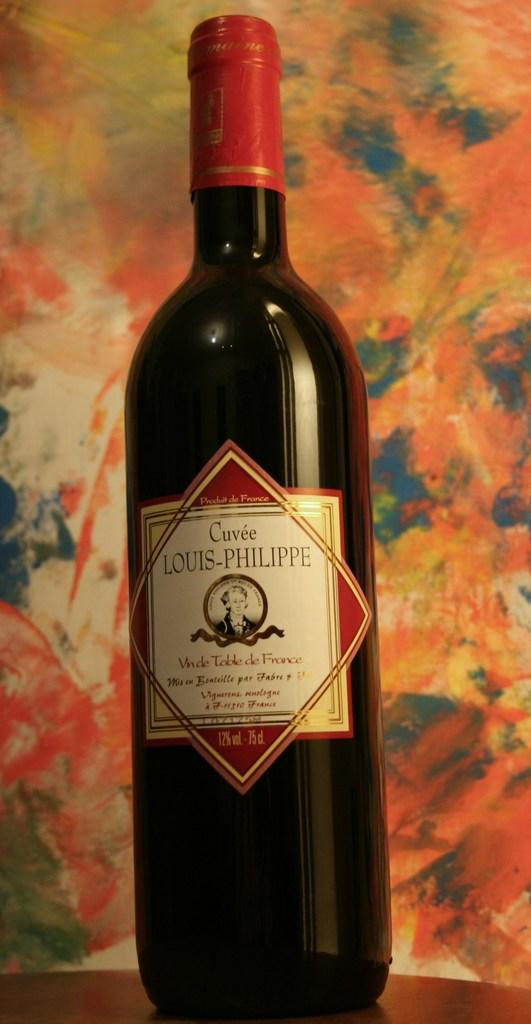<image>
Write a terse but informative summary of the picture. A Cuvee Louis-Philippe wine is sitting on a brown table with a colorful background. 